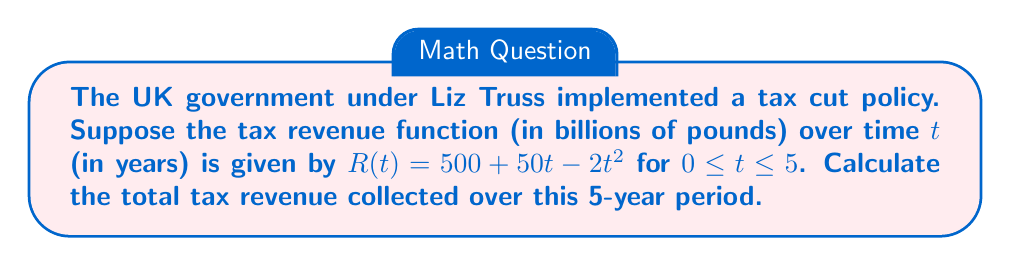Teach me how to tackle this problem. To calculate the total tax revenue over the 5-year period, we need to find the area under the curve $R(t)$ from $t=0$ to $t=5$. This can be done using a definite integral.

1. Set up the definite integral:
   $$\int_0^5 (500 + 50t - 2t^2) dt$$

2. Integrate the function:
   $$\int (500 + 50t - 2t^2) dt = 500t + 25t^2 - \frac{2}{3}t^3 + C$$

3. Apply the limits of integration:
   $$\left[500t + 25t^2 - \frac{2}{3}t^3\right]_0^5$$

4. Evaluate at $t=5$:
   $$500(5) + 25(5^2) - \frac{2}{3}(5^3) = 2500 + 625 - \frac{250}{3} = 3041.67$$

5. Evaluate at $t=0$:
   $$500(0) + 25(0^2) - \frac{2}{3}(0^3) = 0$$

6. Subtract the results:
   $$3041.67 - 0 = 3041.67$$

The total tax revenue collected over the 5-year period is approximately 3041.67 billion pounds.
Answer: £3041.67 billion 